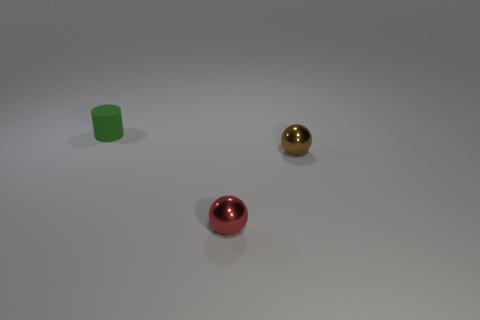What is the material of the object that is right of the small green rubber thing and behind the red metallic ball?
Provide a short and direct response. Metal. There is a tiny object on the right side of the tiny red thing; does it have the same shape as the metal object in front of the small brown sphere?
Provide a succinct answer. Yes. Are there any other things that are the same material as the small red object?
Your answer should be compact. Yes. The tiny metallic thing that is right of the shiny ball on the left side of the small brown object behind the tiny red sphere is what shape?
Make the answer very short. Sphere. What number of other things are the same shape as the green thing?
Offer a terse response. 0. There is another metallic sphere that is the same size as the red ball; what is its color?
Offer a very short reply. Brown. How many cubes are matte objects or red things?
Your response must be concise. 0. What number of cylinders are there?
Provide a short and direct response. 1. Does the matte object have the same shape as the small metallic thing that is in front of the tiny brown ball?
Offer a very short reply. No. How many things are either big brown metal objects or tiny matte cylinders?
Provide a short and direct response. 1. 